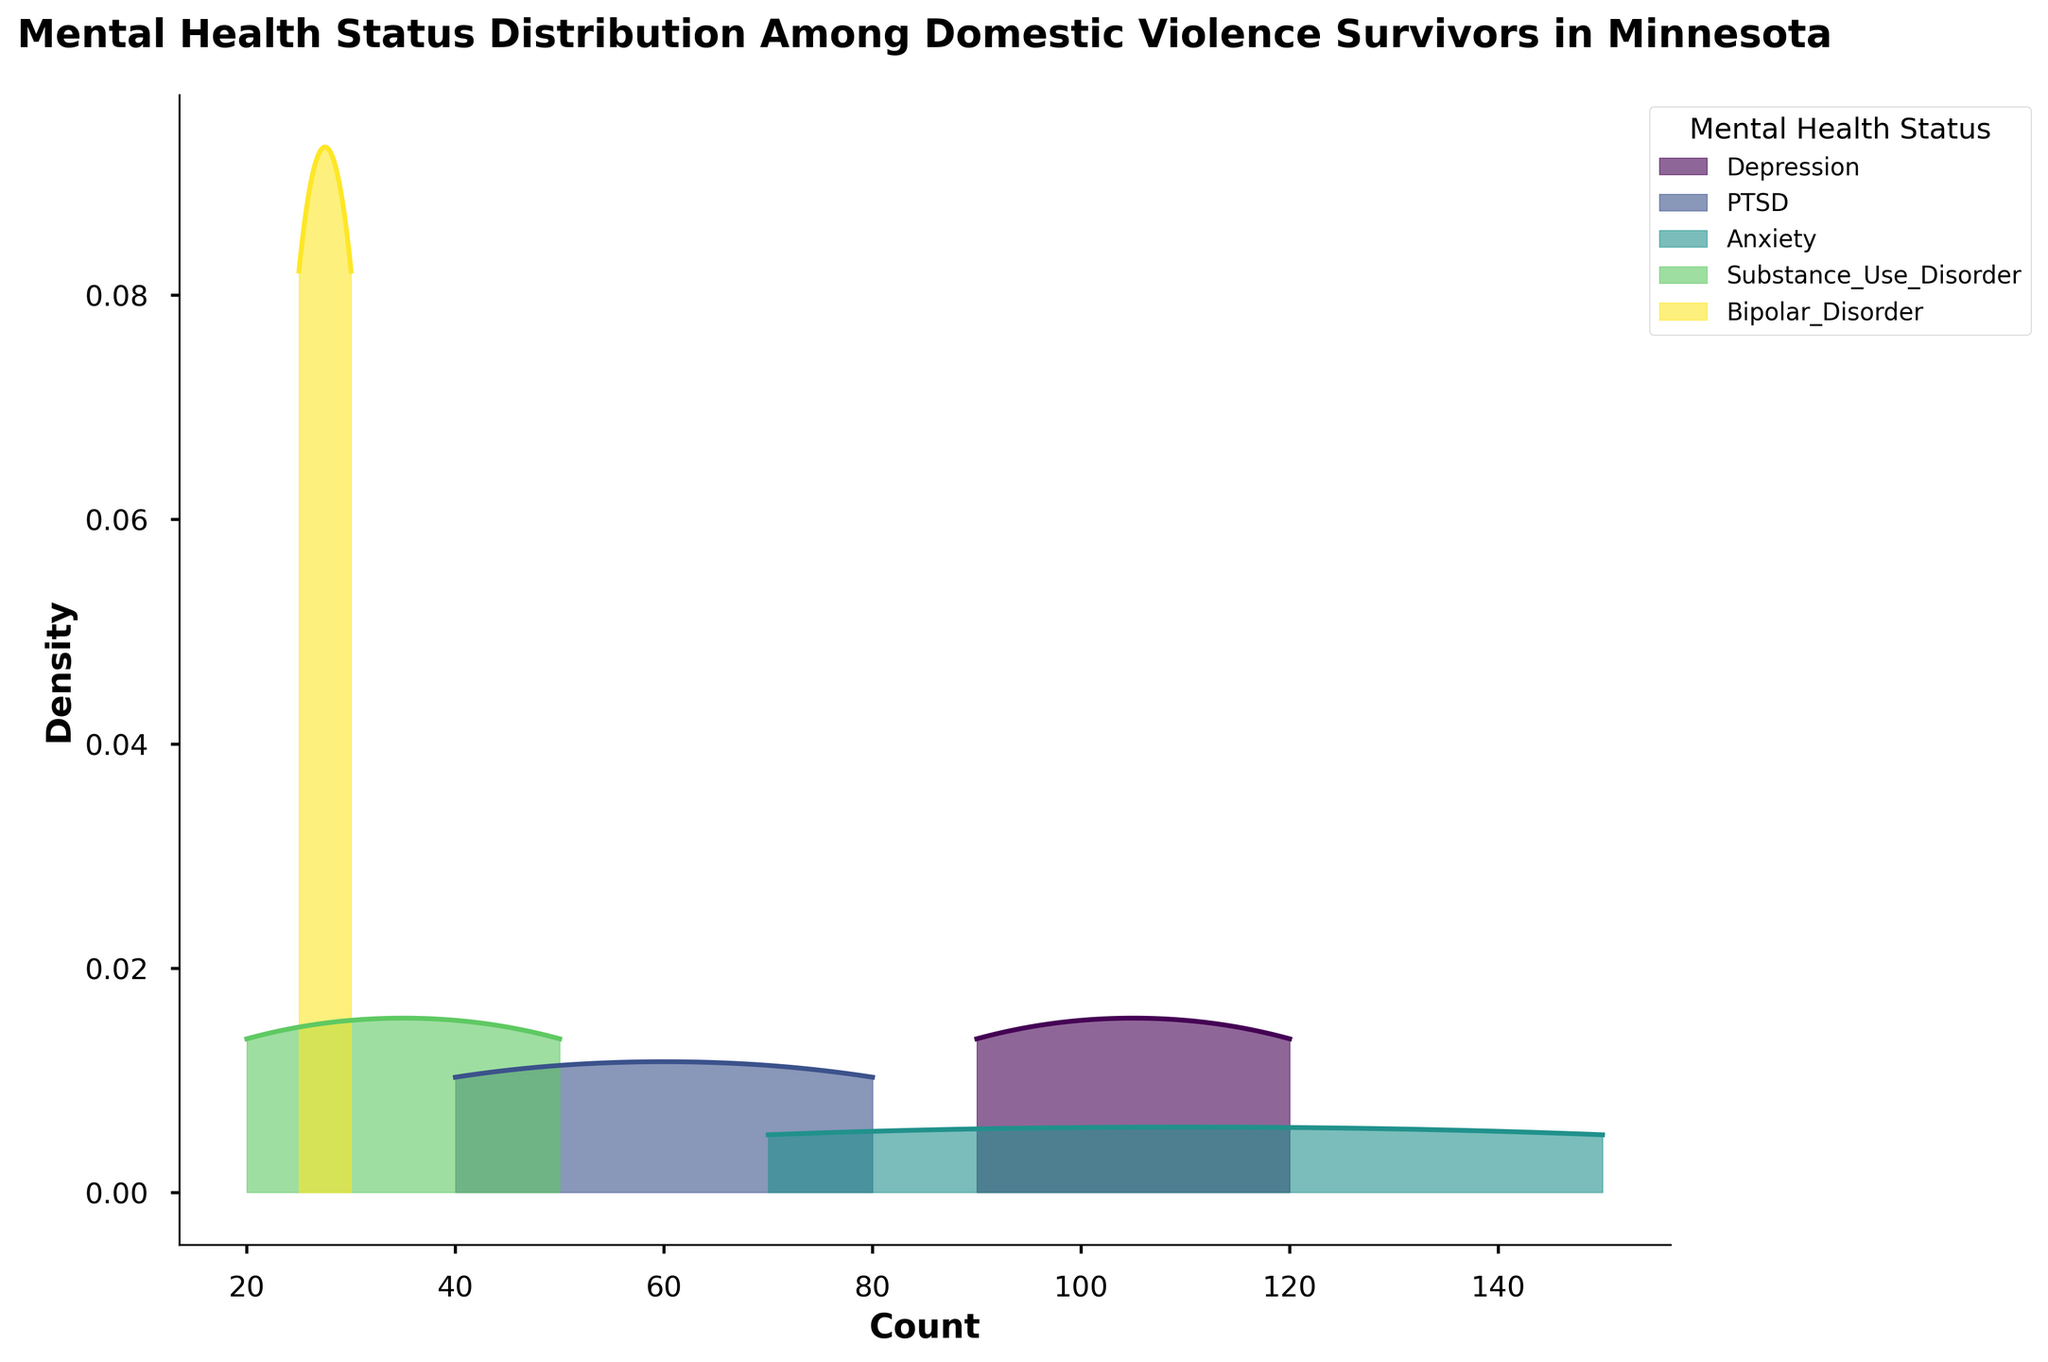What is the title of the figure? The title of the figure is often located at the very top and provides a brief summary of what the figure represents. In this case, it indicates the focus on mental health status distributions.
Answer: Mental Health Status Distribution Among Domestic Violence Survivors in Minnesota What are the labels of the x and y axes? Axis labels provide information about what each axis represents. The x-axis represents the 'Count' of mental health statuses, while the y-axis represents 'Density'.
Answer: Count, Density How many different mental health statuses are shown in the plot? The legend in the upper right corner lists all the mental health statuses included in the figure.
Answer: Five Which mental health status has the highest peak density? By examining the density peaks within the plot, we can determine which status has the highest peak.
Answer: Anxiety Between Depression and PTSD, which has a higher peak density? By comparing the height of the peaks for Depression and PTSD in the plot, we can discern which one is higher.
Answer: PTSD What's the range of counts for Anxiety? The x-axis range over which the density of Anxiety spans can be viewed from the plot.
Answer: 70 to 150 Is the distribution of Bipolar Disorder more spread out or more clustered compared to Depression? By looking at the width of the density curve, we can infer if it is more spread out or clustered. The Bipolar Disorder curve is more narrow compared to the broader spread of Depression.
Answer: More clustered Does Substance Use Disorder have more or fewer high-count observations compared to Bipolar Disorder? By comparing the density curves of Substance Use Disorder and Bipolar Disorder at higher count values, we can see if Substance Use Disorder has fewer high-count observations.
Answer: Fewer Are the density curves for PTSD and Anxiety overlapping significantly? Overlapping would mean that the distribution of counts for PTSD and Anxiety share common values. The plot needs to be checked for significant overlap between these statuses.
Answer: Yes In which county does the highest count for any mental health status occur? The highest count within any of the density curves can be referenced back to the dataset provided or observed directly from the plot. For Anxiety, this highest count is 150 in Dakota.
Answer: Dakota 